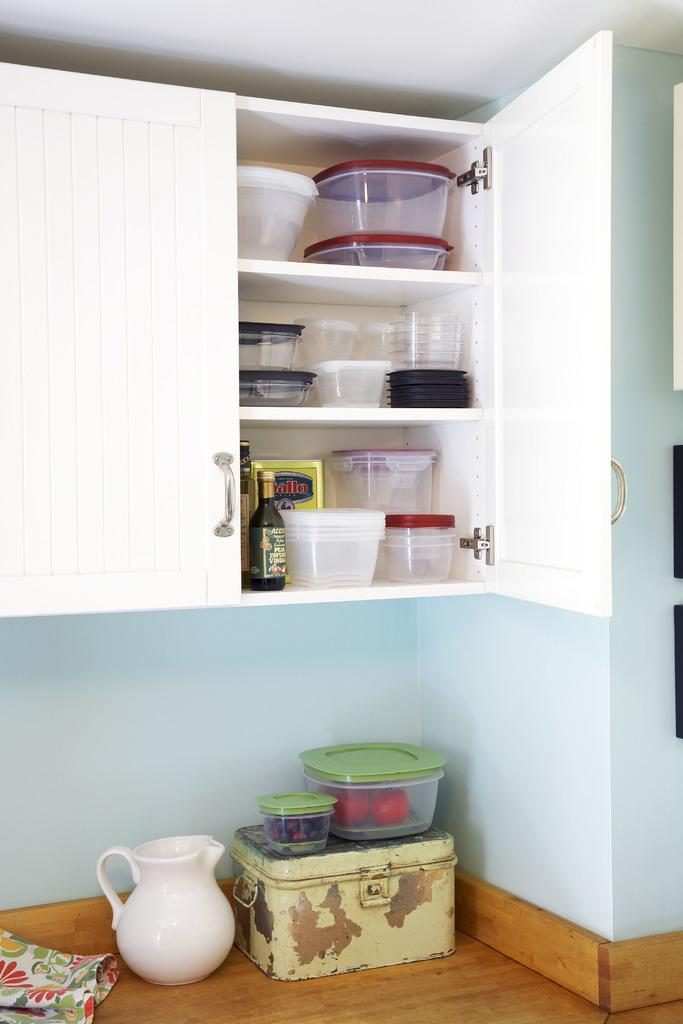What type of containers are visible in the image? There are containers in the image. Can you identify any specific container in the image? Yes, there is a bottle in the image. Where are some of the objects placed in the image? Objects are placed in the racks of a cupboard and on the floor. What is on the floor in the image? There is a white jar and boxes on the floor. What is inside the box on the floor? There are items kept in the box on the floor. What type of insurance policy is being discussed in the image? There is no mention of insurance or any discussion in the image; it primarily focuses on containers, a bottle, and objects placed in a cupboard and on the floor. 